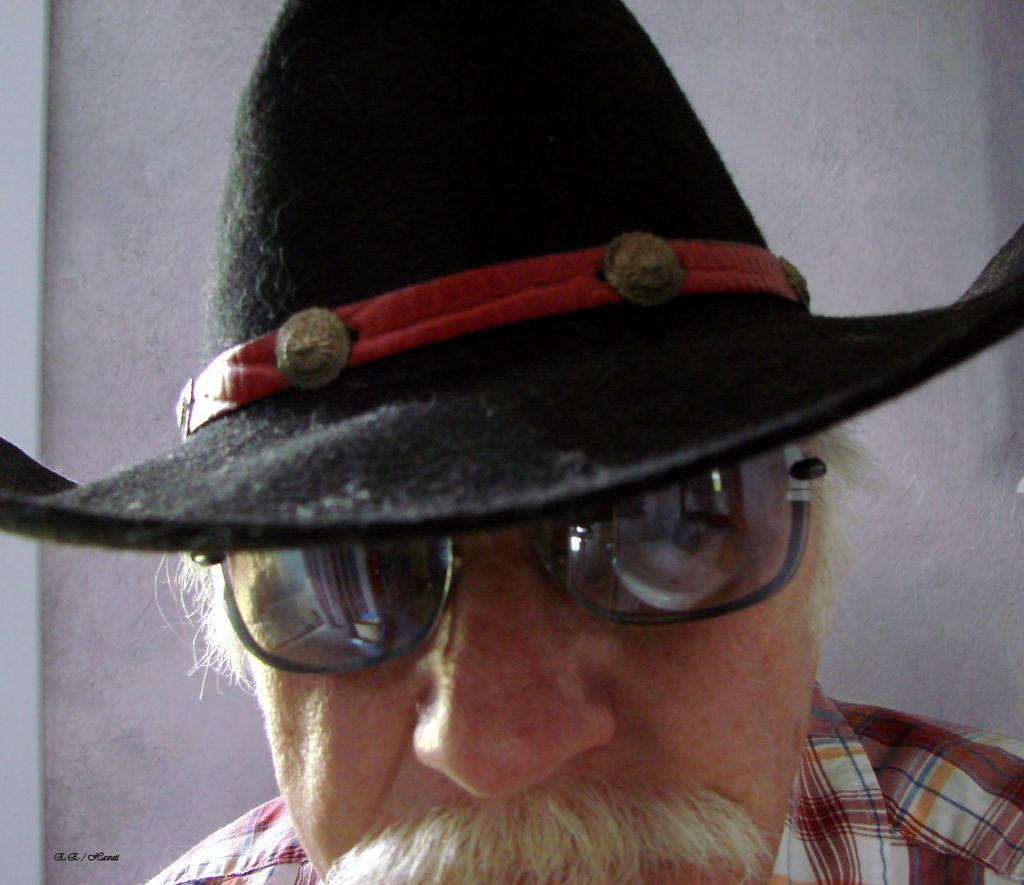What is the main subject of the image? There is a person in the image. What protective gear is the person wearing? The person is wearing goggles. What type of headwear is the person wearing? The person is wearing a hat. What type of lettuce is the person holding in the image? There is no lettuce present in the image; the person is wearing goggles and a hat. 